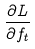<formula> <loc_0><loc_0><loc_500><loc_500>\frac { \partial L } { \partial f _ { t } }</formula> 